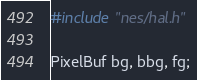<code> <loc_0><loc_0><loc_500><loc_500><_C_>#include "nes/hal.h"

PixelBuf bg, bbg, fg;

</code> 